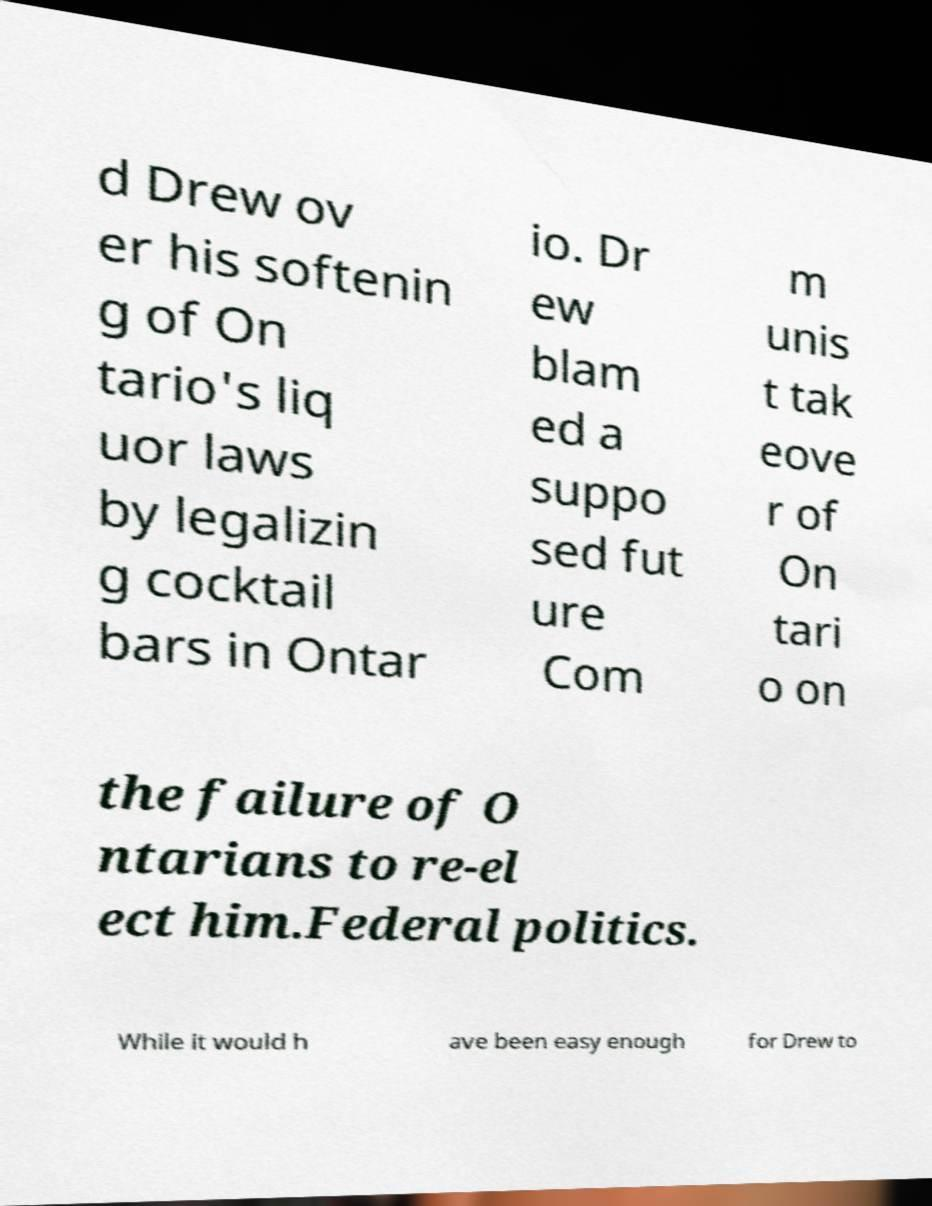What messages or text are displayed in this image? I need them in a readable, typed format. d Drew ov er his softenin g of On tario's liq uor laws by legalizin g cocktail bars in Ontar io. Dr ew blam ed a suppo sed fut ure Com m unis t tak eove r of On tari o on the failure of O ntarians to re-el ect him.Federal politics. While it would h ave been easy enough for Drew to 